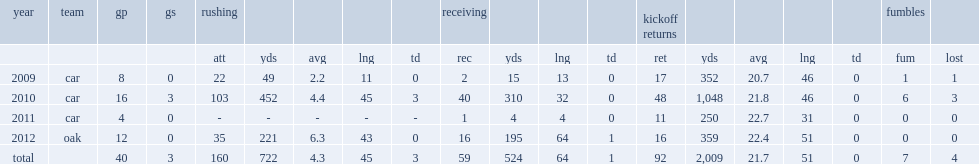How many rushing yards did goodson get in 2010? 452.0. 